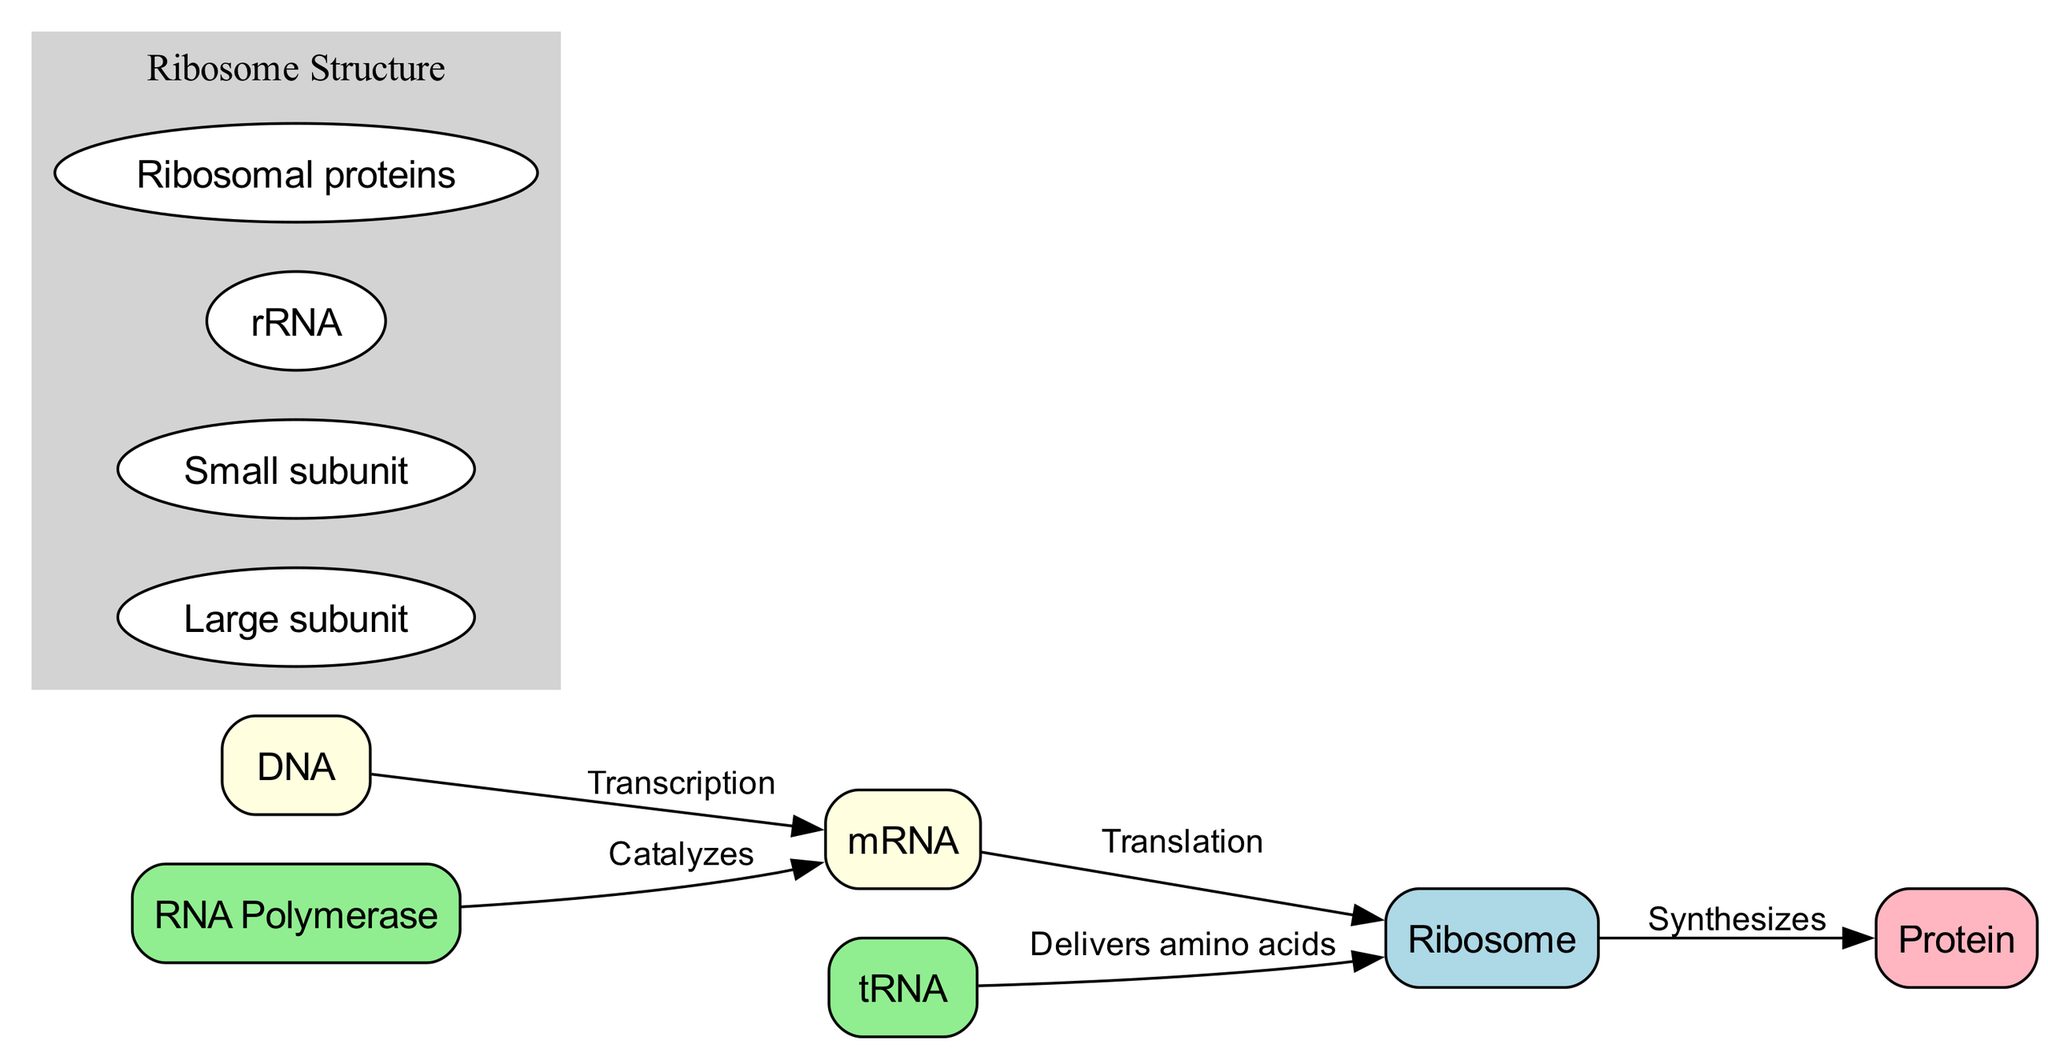What is the starting molecule in the protein synthesis pathway? The diagram shows DNA as the starting point of the protein synthesis pathway. It is labeled as the initial molecule from which transcription begins.
Answer: DNA How many different types of molecules are present in the diagram? There are six unique nodes representing different types of molecules (DNA, RNA Polymerase, mRNA, Ribosome, tRNA, Protein). Each node corresponds to a distinct element in the protein synthesis pathway.
Answer: 6 What process is RNA Polymerase involved in? The diagram indicates that RNA Polymerase catalyzes the transcription process, which is the conversion of DNA into mRNA.
Answer: Catalyzes What does tRNA deliver to the Ribosome? The diagram shows that tRNA is responsible for delivering amino acids to the Ribosome, which are necessary for protein synthesis during translation.
Answer: Amino acids Which two processes are indicated in the diagram? The diagram outlines two key processes: transcription (DNA to mRNA) and translation (mRNA to Protein), each connected by directional edges, indicating the flow of information.
Answer: Transcription and Translation How many components make up the Ribosome structure? The substructure labeled 'Ribosome Structure' includes four components: Large subunit, Small subunit, rRNA, and Ribosomal proteins. This indicates the complexity of the Ribosome as a molecular machine.
Answer: 4 What is the final product of the synthesis pathway? The diagram illustrates that the final product of the entire synthesis process is Protein, highlighting the end goal of the transcription and translation pathway.
Answer: Protein Which molecule is synthesized by the Ribosome? According to the diagram, the Ribosome synthesizes Protein from the information carried by the mRNA during the translation phase.
Answer: Protein 